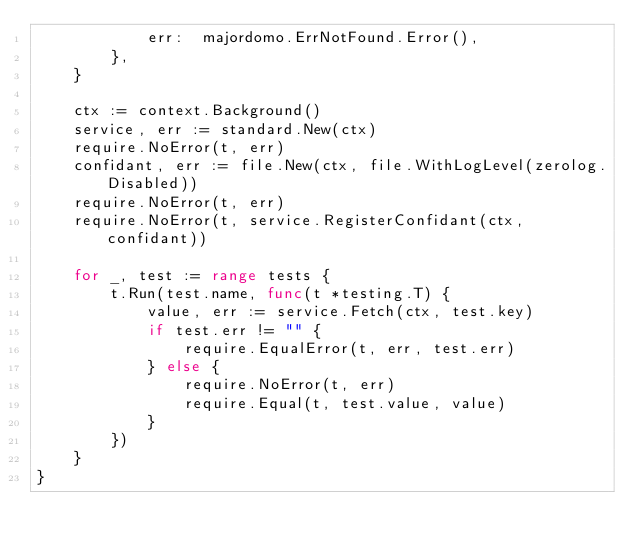<code> <loc_0><loc_0><loc_500><loc_500><_Go_>			err:  majordomo.ErrNotFound.Error(),
		},
	}

	ctx := context.Background()
	service, err := standard.New(ctx)
	require.NoError(t, err)
	confidant, err := file.New(ctx, file.WithLogLevel(zerolog.Disabled))
	require.NoError(t, err)
	require.NoError(t, service.RegisterConfidant(ctx, confidant))

	for _, test := range tests {
		t.Run(test.name, func(t *testing.T) {
			value, err := service.Fetch(ctx, test.key)
			if test.err != "" {
				require.EqualError(t, err, test.err)
			} else {
				require.NoError(t, err)
				require.Equal(t, test.value, value)
			}
		})
	}
}
</code> 